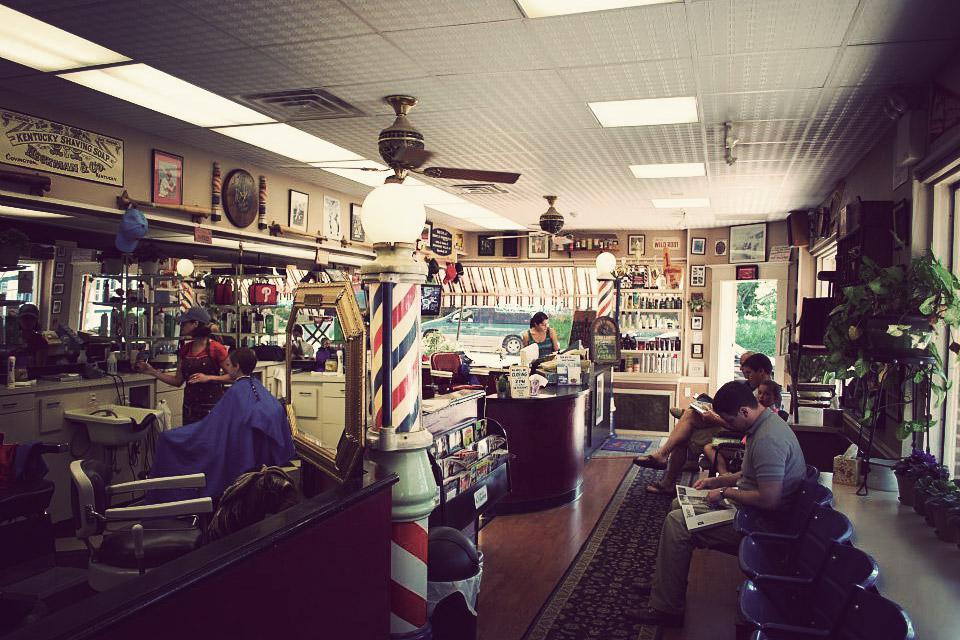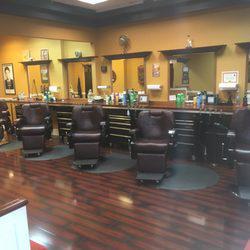The first image is the image on the left, the second image is the image on the right. For the images displayed, is the sentence "There are no people visible in the images." factually correct? Answer yes or no. No. The first image is the image on the left, the second image is the image on the right. Assess this claim about the two images: "there are people in the image on the left". Correct or not? Answer yes or no. Yes. 